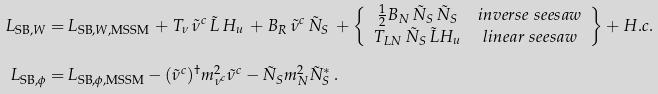<formula> <loc_0><loc_0><loc_500><loc_500>L _ { \text {SB} , W } = \, & L _ { \text {SB} , W , \text {MSSM} } \, + T _ { \nu } \, \tilde { \nu } ^ { c } \, \tilde { L } \, H _ { u } \, + B _ { R } \, \tilde { \nu } ^ { c } \, { \tilde { N } } _ { S } \, + \left \{ \begin{array} { c c } \frac { 1 } { 2 } B _ { N } \, { \tilde { N } } _ { S } \, { \tilde { N } } _ { S } & i n v e r s e \ s e e s a w \\ T _ { L N } \, { \tilde { N } } _ { S } \, \tilde { L } H _ { u } & l i n e a r \ s e e s a w \end{array} \right \} + H . c . \\ L _ { \text {SB} , \phi } = \, & L _ { \text {SB} , \phi , \text {MSSM} } - ( \tilde { \nu } ^ { c } ) ^ { \dagger } { m _ { \nu ^ { c } } ^ { 2 } } \tilde { \nu } ^ { c } - { \tilde { N } } _ { S } m _ { N } ^ { 2 } { \tilde { N } } _ { S } ^ { \ast } \, .</formula> 